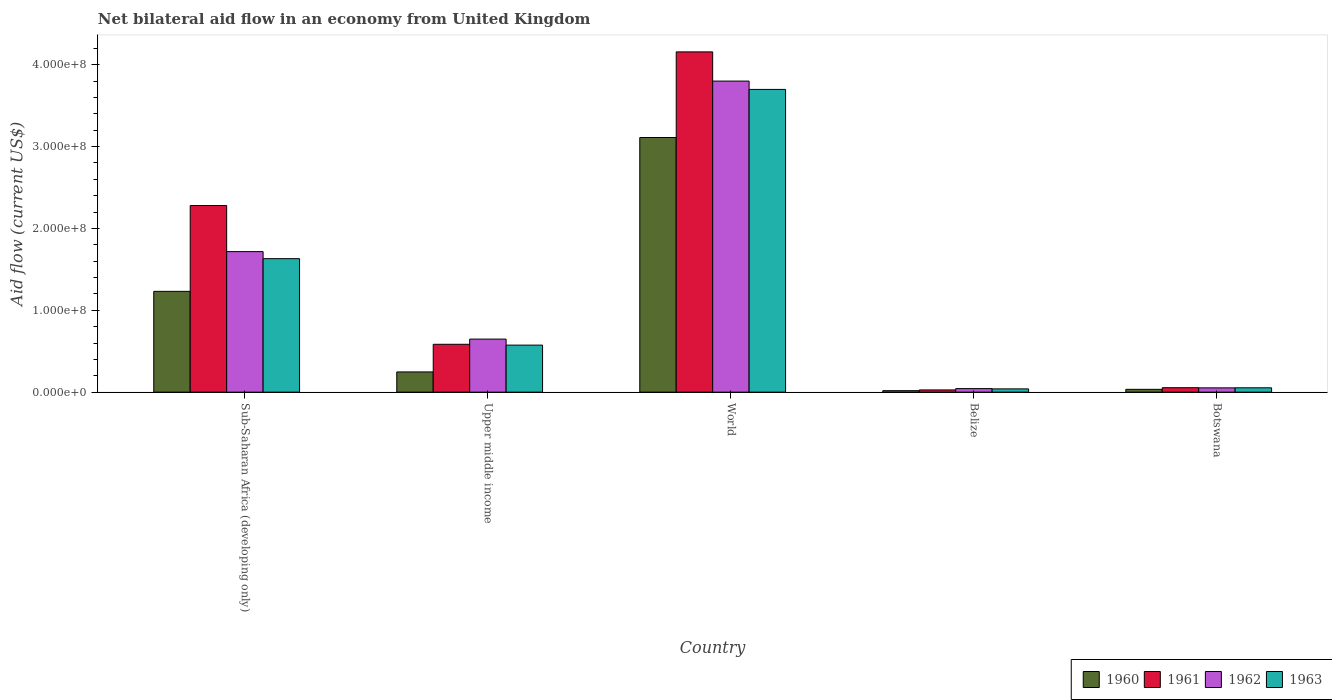How many different coloured bars are there?
Offer a very short reply. 4. Are the number of bars on each tick of the X-axis equal?
Ensure brevity in your answer.  Yes. What is the label of the 5th group of bars from the left?
Provide a succinct answer. Botswana. What is the net bilateral aid flow in 1961 in Upper middle income?
Offer a terse response. 5.85e+07. Across all countries, what is the maximum net bilateral aid flow in 1962?
Offer a very short reply. 3.80e+08. Across all countries, what is the minimum net bilateral aid flow in 1962?
Ensure brevity in your answer.  4.33e+06. In which country was the net bilateral aid flow in 1963 minimum?
Offer a terse response. Belize. What is the total net bilateral aid flow in 1963 in the graph?
Provide a short and direct response. 6.00e+08. What is the difference between the net bilateral aid flow in 1962 in Upper middle income and that in World?
Your answer should be very brief. -3.15e+08. What is the difference between the net bilateral aid flow in 1962 in Botswana and the net bilateral aid flow in 1960 in World?
Offer a terse response. -3.06e+08. What is the average net bilateral aid flow in 1963 per country?
Give a very brief answer. 1.20e+08. What is the difference between the net bilateral aid flow of/in 1963 and net bilateral aid flow of/in 1960 in World?
Offer a terse response. 5.88e+07. In how many countries, is the net bilateral aid flow in 1960 greater than 400000000 US$?
Your answer should be very brief. 0. What is the ratio of the net bilateral aid flow in 1961 in Belize to that in Sub-Saharan Africa (developing only)?
Your answer should be compact. 0.01. Is the difference between the net bilateral aid flow in 1963 in Botswana and Sub-Saharan Africa (developing only) greater than the difference between the net bilateral aid flow in 1960 in Botswana and Sub-Saharan Africa (developing only)?
Provide a succinct answer. No. What is the difference between the highest and the second highest net bilateral aid flow in 1963?
Offer a very short reply. 3.12e+08. What is the difference between the highest and the lowest net bilateral aid flow in 1960?
Provide a succinct answer. 3.09e+08. What does the 2nd bar from the right in Upper middle income represents?
Provide a short and direct response. 1962. How many countries are there in the graph?
Make the answer very short. 5. What is the difference between two consecutive major ticks on the Y-axis?
Make the answer very short. 1.00e+08. Are the values on the major ticks of Y-axis written in scientific E-notation?
Make the answer very short. Yes. How many legend labels are there?
Offer a terse response. 4. How are the legend labels stacked?
Give a very brief answer. Horizontal. What is the title of the graph?
Keep it short and to the point. Net bilateral aid flow in an economy from United Kingdom. Does "1967" appear as one of the legend labels in the graph?
Your answer should be very brief. No. What is the label or title of the X-axis?
Keep it short and to the point. Country. What is the label or title of the Y-axis?
Offer a very short reply. Aid flow (current US$). What is the Aid flow (current US$) of 1960 in Sub-Saharan Africa (developing only)?
Ensure brevity in your answer.  1.23e+08. What is the Aid flow (current US$) in 1961 in Sub-Saharan Africa (developing only)?
Ensure brevity in your answer.  2.28e+08. What is the Aid flow (current US$) of 1962 in Sub-Saharan Africa (developing only)?
Ensure brevity in your answer.  1.72e+08. What is the Aid flow (current US$) in 1963 in Sub-Saharan Africa (developing only)?
Ensure brevity in your answer.  1.63e+08. What is the Aid flow (current US$) in 1960 in Upper middle income?
Your answer should be compact. 2.47e+07. What is the Aid flow (current US$) in 1961 in Upper middle income?
Make the answer very short. 5.85e+07. What is the Aid flow (current US$) of 1962 in Upper middle income?
Keep it short and to the point. 6.48e+07. What is the Aid flow (current US$) of 1963 in Upper middle income?
Your answer should be compact. 5.74e+07. What is the Aid flow (current US$) of 1960 in World?
Provide a succinct answer. 3.11e+08. What is the Aid flow (current US$) of 1961 in World?
Keep it short and to the point. 4.16e+08. What is the Aid flow (current US$) in 1962 in World?
Provide a short and direct response. 3.80e+08. What is the Aid flow (current US$) in 1963 in World?
Ensure brevity in your answer.  3.70e+08. What is the Aid flow (current US$) of 1960 in Belize?
Give a very brief answer. 1.79e+06. What is the Aid flow (current US$) in 1961 in Belize?
Make the answer very short. 2.70e+06. What is the Aid flow (current US$) of 1962 in Belize?
Provide a short and direct response. 4.33e+06. What is the Aid flow (current US$) in 1963 in Belize?
Your response must be concise. 3.99e+06. What is the Aid flow (current US$) of 1960 in Botswana?
Offer a terse response. 3.43e+06. What is the Aid flow (current US$) in 1961 in Botswana?
Your answer should be compact. 5.44e+06. What is the Aid flow (current US$) of 1962 in Botswana?
Keep it short and to the point. 5.22e+06. What is the Aid flow (current US$) in 1963 in Botswana?
Offer a terse response. 5.30e+06. Across all countries, what is the maximum Aid flow (current US$) of 1960?
Give a very brief answer. 3.11e+08. Across all countries, what is the maximum Aid flow (current US$) in 1961?
Your answer should be very brief. 4.16e+08. Across all countries, what is the maximum Aid flow (current US$) in 1962?
Provide a short and direct response. 3.80e+08. Across all countries, what is the maximum Aid flow (current US$) of 1963?
Ensure brevity in your answer.  3.70e+08. Across all countries, what is the minimum Aid flow (current US$) in 1960?
Your answer should be very brief. 1.79e+06. Across all countries, what is the minimum Aid flow (current US$) in 1961?
Give a very brief answer. 2.70e+06. Across all countries, what is the minimum Aid flow (current US$) in 1962?
Keep it short and to the point. 4.33e+06. Across all countries, what is the minimum Aid flow (current US$) in 1963?
Your response must be concise. 3.99e+06. What is the total Aid flow (current US$) of 1960 in the graph?
Ensure brevity in your answer.  4.64e+08. What is the total Aid flow (current US$) of 1961 in the graph?
Keep it short and to the point. 7.10e+08. What is the total Aid flow (current US$) in 1962 in the graph?
Keep it short and to the point. 6.26e+08. What is the total Aid flow (current US$) in 1963 in the graph?
Your response must be concise. 6.00e+08. What is the difference between the Aid flow (current US$) of 1960 in Sub-Saharan Africa (developing only) and that in Upper middle income?
Your answer should be very brief. 9.84e+07. What is the difference between the Aid flow (current US$) in 1961 in Sub-Saharan Africa (developing only) and that in Upper middle income?
Your answer should be compact. 1.69e+08. What is the difference between the Aid flow (current US$) of 1962 in Sub-Saharan Africa (developing only) and that in Upper middle income?
Provide a succinct answer. 1.07e+08. What is the difference between the Aid flow (current US$) in 1963 in Sub-Saharan Africa (developing only) and that in Upper middle income?
Your response must be concise. 1.06e+08. What is the difference between the Aid flow (current US$) in 1960 in Sub-Saharan Africa (developing only) and that in World?
Your answer should be compact. -1.88e+08. What is the difference between the Aid flow (current US$) of 1961 in Sub-Saharan Africa (developing only) and that in World?
Your response must be concise. -1.88e+08. What is the difference between the Aid flow (current US$) of 1962 in Sub-Saharan Africa (developing only) and that in World?
Offer a very short reply. -2.08e+08. What is the difference between the Aid flow (current US$) in 1963 in Sub-Saharan Africa (developing only) and that in World?
Ensure brevity in your answer.  -2.07e+08. What is the difference between the Aid flow (current US$) in 1960 in Sub-Saharan Africa (developing only) and that in Belize?
Your answer should be compact. 1.21e+08. What is the difference between the Aid flow (current US$) of 1961 in Sub-Saharan Africa (developing only) and that in Belize?
Provide a short and direct response. 2.25e+08. What is the difference between the Aid flow (current US$) of 1962 in Sub-Saharan Africa (developing only) and that in Belize?
Your answer should be compact. 1.67e+08. What is the difference between the Aid flow (current US$) of 1963 in Sub-Saharan Africa (developing only) and that in Belize?
Provide a succinct answer. 1.59e+08. What is the difference between the Aid flow (current US$) in 1960 in Sub-Saharan Africa (developing only) and that in Botswana?
Make the answer very short. 1.20e+08. What is the difference between the Aid flow (current US$) of 1961 in Sub-Saharan Africa (developing only) and that in Botswana?
Your response must be concise. 2.22e+08. What is the difference between the Aid flow (current US$) in 1962 in Sub-Saharan Africa (developing only) and that in Botswana?
Offer a terse response. 1.66e+08. What is the difference between the Aid flow (current US$) of 1963 in Sub-Saharan Africa (developing only) and that in Botswana?
Give a very brief answer. 1.58e+08. What is the difference between the Aid flow (current US$) of 1960 in Upper middle income and that in World?
Provide a short and direct response. -2.86e+08. What is the difference between the Aid flow (current US$) in 1961 in Upper middle income and that in World?
Your answer should be very brief. -3.57e+08. What is the difference between the Aid flow (current US$) in 1962 in Upper middle income and that in World?
Offer a terse response. -3.15e+08. What is the difference between the Aid flow (current US$) of 1963 in Upper middle income and that in World?
Your answer should be compact. -3.12e+08. What is the difference between the Aid flow (current US$) of 1960 in Upper middle income and that in Belize?
Offer a terse response. 2.29e+07. What is the difference between the Aid flow (current US$) in 1961 in Upper middle income and that in Belize?
Ensure brevity in your answer.  5.58e+07. What is the difference between the Aid flow (current US$) of 1962 in Upper middle income and that in Belize?
Your answer should be compact. 6.05e+07. What is the difference between the Aid flow (current US$) in 1963 in Upper middle income and that in Belize?
Provide a succinct answer. 5.35e+07. What is the difference between the Aid flow (current US$) in 1960 in Upper middle income and that in Botswana?
Your response must be concise. 2.13e+07. What is the difference between the Aid flow (current US$) in 1961 in Upper middle income and that in Botswana?
Make the answer very short. 5.30e+07. What is the difference between the Aid flow (current US$) of 1962 in Upper middle income and that in Botswana?
Your response must be concise. 5.96e+07. What is the difference between the Aid flow (current US$) of 1963 in Upper middle income and that in Botswana?
Your response must be concise. 5.22e+07. What is the difference between the Aid flow (current US$) in 1960 in World and that in Belize?
Provide a succinct answer. 3.09e+08. What is the difference between the Aid flow (current US$) of 1961 in World and that in Belize?
Provide a succinct answer. 4.13e+08. What is the difference between the Aid flow (current US$) of 1962 in World and that in Belize?
Your answer should be very brief. 3.76e+08. What is the difference between the Aid flow (current US$) in 1963 in World and that in Belize?
Make the answer very short. 3.66e+08. What is the difference between the Aid flow (current US$) in 1960 in World and that in Botswana?
Your response must be concise. 3.08e+08. What is the difference between the Aid flow (current US$) in 1961 in World and that in Botswana?
Provide a short and direct response. 4.10e+08. What is the difference between the Aid flow (current US$) in 1962 in World and that in Botswana?
Provide a short and direct response. 3.75e+08. What is the difference between the Aid flow (current US$) of 1963 in World and that in Botswana?
Provide a short and direct response. 3.65e+08. What is the difference between the Aid flow (current US$) of 1960 in Belize and that in Botswana?
Provide a succinct answer. -1.64e+06. What is the difference between the Aid flow (current US$) of 1961 in Belize and that in Botswana?
Offer a terse response. -2.74e+06. What is the difference between the Aid flow (current US$) of 1962 in Belize and that in Botswana?
Your response must be concise. -8.90e+05. What is the difference between the Aid flow (current US$) in 1963 in Belize and that in Botswana?
Offer a terse response. -1.31e+06. What is the difference between the Aid flow (current US$) of 1960 in Sub-Saharan Africa (developing only) and the Aid flow (current US$) of 1961 in Upper middle income?
Offer a very short reply. 6.47e+07. What is the difference between the Aid flow (current US$) of 1960 in Sub-Saharan Africa (developing only) and the Aid flow (current US$) of 1962 in Upper middle income?
Ensure brevity in your answer.  5.83e+07. What is the difference between the Aid flow (current US$) in 1960 in Sub-Saharan Africa (developing only) and the Aid flow (current US$) in 1963 in Upper middle income?
Your answer should be compact. 6.57e+07. What is the difference between the Aid flow (current US$) of 1961 in Sub-Saharan Africa (developing only) and the Aid flow (current US$) of 1962 in Upper middle income?
Provide a succinct answer. 1.63e+08. What is the difference between the Aid flow (current US$) of 1961 in Sub-Saharan Africa (developing only) and the Aid flow (current US$) of 1963 in Upper middle income?
Give a very brief answer. 1.70e+08. What is the difference between the Aid flow (current US$) of 1962 in Sub-Saharan Africa (developing only) and the Aid flow (current US$) of 1963 in Upper middle income?
Your answer should be compact. 1.14e+08. What is the difference between the Aid flow (current US$) in 1960 in Sub-Saharan Africa (developing only) and the Aid flow (current US$) in 1961 in World?
Provide a succinct answer. -2.93e+08. What is the difference between the Aid flow (current US$) in 1960 in Sub-Saharan Africa (developing only) and the Aid flow (current US$) in 1962 in World?
Give a very brief answer. -2.57e+08. What is the difference between the Aid flow (current US$) of 1960 in Sub-Saharan Africa (developing only) and the Aid flow (current US$) of 1963 in World?
Provide a succinct answer. -2.47e+08. What is the difference between the Aid flow (current US$) of 1961 in Sub-Saharan Africa (developing only) and the Aid flow (current US$) of 1962 in World?
Make the answer very short. -1.52e+08. What is the difference between the Aid flow (current US$) of 1961 in Sub-Saharan Africa (developing only) and the Aid flow (current US$) of 1963 in World?
Offer a terse response. -1.42e+08. What is the difference between the Aid flow (current US$) in 1962 in Sub-Saharan Africa (developing only) and the Aid flow (current US$) in 1963 in World?
Give a very brief answer. -1.98e+08. What is the difference between the Aid flow (current US$) of 1960 in Sub-Saharan Africa (developing only) and the Aid flow (current US$) of 1961 in Belize?
Give a very brief answer. 1.20e+08. What is the difference between the Aid flow (current US$) of 1960 in Sub-Saharan Africa (developing only) and the Aid flow (current US$) of 1962 in Belize?
Offer a terse response. 1.19e+08. What is the difference between the Aid flow (current US$) in 1960 in Sub-Saharan Africa (developing only) and the Aid flow (current US$) in 1963 in Belize?
Your answer should be very brief. 1.19e+08. What is the difference between the Aid flow (current US$) of 1961 in Sub-Saharan Africa (developing only) and the Aid flow (current US$) of 1962 in Belize?
Keep it short and to the point. 2.24e+08. What is the difference between the Aid flow (current US$) in 1961 in Sub-Saharan Africa (developing only) and the Aid flow (current US$) in 1963 in Belize?
Make the answer very short. 2.24e+08. What is the difference between the Aid flow (current US$) in 1962 in Sub-Saharan Africa (developing only) and the Aid flow (current US$) in 1963 in Belize?
Provide a succinct answer. 1.68e+08. What is the difference between the Aid flow (current US$) of 1960 in Sub-Saharan Africa (developing only) and the Aid flow (current US$) of 1961 in Botswana?
Ensure brevity in your answer.  1.18e+08. What is the difference between the Aid flow (current US$) in 1960 in Sub-Saharan Africa (developing only) and the Aid flow (current US$) in 1962 in Botswana?
Offer a terse response. 1.18e+08. What is the difference between the Aid flow (current US$) in 1960 in Sub-Saharan Africa (developing only) and the Aid flow (current US$) in 1963 in Botswana?
Offer a very short reply. 1.18e+08. What is the difference between the Aid flow (current US$) of 1961 in Sub-Saharan Africa (developing only) and the Aid flow (current US$) of 1962 in Botswana?
Ensure brevity in your answer.  2.23e+08. What is the difference between the Aid flow (current US$) of 1961 in Sub-Saharan Africa (developing only) and the Aid flow (current US$) of 1963 in Botswana?
Give a very brief answer. 2.23e+08. What is the difference between the Aid flow (current US$) in 1962 in Sub-Saharan Africa (developing only) and the Aid flow (current US$) in 1963 in Botswana?
Ensure brevity in your answer.  1.66e+08. What is the difference between the Aid flow (current US$) in 1960 in Upper middle income and the Aid flow (current US$) in 1961 in World?
Your response must be concise. -3.91e+08. What is the difference between the Aid flow (current US$) in 1960 in Upper middle income and the Aid flow (current US$) in 1962 in World?
Your answer should be compact. -3.55e+08. What is the difference between the Aid flow (current US$) in 1960 in Upper middle income and the Aid flow (current US$) in 1963 in World?
Provide a succinct answer. -3.45e+08. What is the difference between the Aid flow (current US$) in 1961 in Upper middle income and the Aid flow (current US$) in 1962 in World?
Keep it short and to the point. -3.22e+08. What is the difference between the Aid flow (current US$) of 1961 in Upper middle income and the Aid flow (current US$) of 1963 in World?
Your answer should be compact. -3.11e+08. What is the difference between the Aid flow (current US$) of 1962 in Upper middle income and the Aid flow (current US$) of 1963 in World?
Your response must be concise. -3.05e+08. What is the difference between the Aid flow (current US$) of 1960 in Upper middle income and the Aid flow (current US$) of 1961 in Belize?
Your answer should be very brief. 2.20e+07. What is the difference between the Aid flow (current US$) of 1960 in Upper middle income and the Aid flow (current US$) of 1962 in Belize?
Give a very brief answer. 2.04e+07. What is the difference between the Aid flow (current US$) of 1960 in Upper middle income and the Aid flow (current US$) of 1963 in Belize?
Offer a very short reply. 2.07e+07. What is the difference between the Aid flow (current US$) of 1961 in Upper middle income and the Aid flow (current US$) of 1962 in Belize?
Provide a short and direct response. 5.41e+07. What is the difference between the Aid flow (current US$) of 1961 in Upper middle income and the Aid flow (current US$) of 1963 in Belize?
Your answer should be very brief. 5.45e+07. What is the difference between the Aid flow (current US$) in 1962 in Upper middle income and the Aid flow (current US$) in 1963 in Belize?
Provide a short and direct response. 6.08e+07. What is the difference between the Aid flow (current US$) of 1960 in Upper middle income and the Aid flow (current US$) of 1961 in Botswana?
Provide a short and direct response. 1.93e+07. What is the difference between the Aid flow (current US$) in 1960 in Upper middle income and the Aid flow (current US$) in 1962 in Botswana?
Give a very brief answer. 1.95e+07. What is the difference between the Aid flow (current US$) in 1960 in Upper middle income and the Aid flow (current US$) in 1963 in Botswana?
Offer a very short reply. 1.94e+07. What is the difference between the Aid flow (current US$) in 1961 in Upper middle income and the Aid flow (current US$) in 1962 in Botswana?
Provide a succinct answer. 5.32e+07. What is the difference between the Aid flow (current US$) in 1961 in Upper middle income and the Aid flow (current US$) in 1963 in Botswana?
Offer a very short reply. 5.32e+07. What is the difference between the Aid flow (current US$) in 1962 in Upper middle income and the Aid flow (current US$) in 1963 in Botswana?
Make the answer very short. 5.95e+07. What is the difference between the Aid flow (current US$) of 1960 in World and the Aid flow (current US$) of 1961 in Belize?
Your answer should be very brief. 3.08e+08. What is the difference between the Aid flow (current US$) of 1960 in World and the Aid flow (current US$) of 1962 in Belize?
Ensure brevity in your answer.  3.07e+08. What is the difference between the Aid flow (current US$) of 1960 in World and the Aid flow (current US$) of 1963 in Belize?
Offer a terse response. 3.07e+08. What is the difference between the Aid flow (current US$) in 1961 in World and the Aid flow (current US$) in 1962 in Belize?
Keep it short and to the point. 4.11e+08. What is the difference between the Aid flow (current US$) of 1961 in World and the Aid flow (current US$) of 1963 in Belize?
Provide a succinct answer. 4.12e+08. What is the difference between the Aid flow (current US$) of 1962 in World and the Aid flow (current US$) of 1963 in Belize?
Give a very brief answer. 3.76e+08. What is the difference between the Aid flow (current US$) in 1960 in World and the Aid flow (current US$) in 1961 in Botswana?
Offer a very short reply. 3.06e+08. What is the difference between the Aid flow (current US$) in 1960 in World and the Aid flow (current US$) in 1962 in Botswana?
Your response must be concise. 3.06e+08. What is the difference between the Aid flow (current US$) of 1960 in World and the Aid flow (current US$) of 1963 in Botswana?
Keep it short and to the point. 3.06e+08. What is the difference between the Aid flow (current US$) of 1961 in World and the Aid flow (current US$) of 1962 in Botswana?
Give a very brief answer. 4.10e+08. What is the difference between the Aid flow (current US$) in 1961 in World and the Aid flow (current US$) in 1963 in Botswana?
Provide a succinct answer. 4.10e+08. What is the difference between the Aid flow (current US$) in 1962 in World and the Aid flow (current US$) in 1963 in Botswana?
Offer a very short reply. 3.75e+08. What is the difference between the Aid flow (current US$) in 1960 in Belize and the Aid flow (current US$) in 1961 in Botswana?
Provide a short and direct response. -3.65e+06. What is the difference between the Aid flow (current US$) of 1960 in Belize and the Aid flow (current US$) of 1962 in Botswana?
Give a very brief answer. -3.43e+06. What is the difference between the Aid flow (current US$) of 1960 in Belize and the Aid flow (current US$) of 1963 in Botswana?
Your response must be concise. -3.51e+06. What is the difference between the Aid flow (current US$) of 1961 in Belize and the Aid flow (current US$) of 1962 in Botswana?
Offer a terse response. -2.52e+06. What is the difference between the Aid flow (current US$) in 1961 in Belize and the Aid flow (current US$) in 1963 in Botswana?
Your response must be concise. -2.60e+06. What is the difference between the Aid flow (current US$) in 1962 in Belize and the Aid flow (current US$) in 1963 in Botswana?
Offer a very short reply. -9.70e+05. What is the average Aid flow (current US$) in 1960 per country?
Provide a short and direct response. 9.28e+07. What is the average Aid flow (current US$) in 1961 per country?
Your response must be concise. 1.42e+08. What is the average Aid flow (current US$) in 1962 per country?
Provide a succinct answer. 1.25e+08. What is the average Aid flow (current US$) of 1963 per country?
Provide a short and direct response. 1.20e+08. What is the difference between the Aid flow (current US$) in 1960 and Aid flow (current US$) in 1961 in Sub-Saharan Africa (developing only)?
Provide a short and direct response. -1.05e+08. What is the difference between the Aid flow (current US$) of 1960 and Aid flow (current US$) of 1962 in Sub-Saharan Africa (developing only)?
Provide a succinct answer. -4.85e+07. What is the difference between the Aid flow (current US$) in 1960 and Aid flow (current US$) in 1963 in Sub-Saharan Africa (developing only)?
Keep it short and to the point. -3.99e+07. What is the difference between the Aid flow (current US$) in 1961 and Aid flow (current US$) in 1962 in Sub-Saharan Africa (developing only)?
Offer a terse response. 5.63e+07. What is the difference between the Aid flow (current US$) of 1961 and Aid flow (current US$) of 1963 in Sub-Saharan Africa (developing only)?
Ensure brevity in your answer.  6.49e+07. What is the difference between the Aid flow (current US$) of 1962 and Aid flow (current US$) of 1963 in Sub-Saharan Africa (developing only)?
Your response must be concise. 8.61e+06. What is the difference between the Aid flow (current US$) of 1960 and Aid flow (current US$) of 1961 in Upper middle income?
Make the answer very short. -3.38e+07. What is the difference between the Aid flow (current US$) of 1960 and Aid flow (current US$) of 1962 in Upper middle income?
Provide a succinct answer. -4.01e+07. What is the difference between the Aid flow (current US$) in 1960 and Aid flow (current US$) in 1963 in Upper middle income?
Your answer should be very brief. -3.28e+07. What is the difference between the Aid flow (current US$) of 1961 and Aid flow (current US$) of 1962 in Upper middle income?
Ensure brevity in your answer.  -6.33e+06. What is the difference between the Aid flow (current US$) in 1961 and Aid flow (current US$) in 1963 in Upper middle income?
Provide a succinct answer. 1.02e+06. What is the difference between the Aid flow (current US$) in 1962 and Aid flow (current US$) in 1963 in Upper middle income?
Provide a short and direct response. 7.35e+06. What is the difference between the Aid flow (current US$) of 1960 and Aid flow (current US$) of 1961 in World?
Ensure brevity in your answer.  -1.05e+08. What is the difference between the Aid flow (current US$) of 1960 and Aid flow (current US$) of 1962 in World?
Offer a terse response. -6.89e+07. What is the difference between the Aid flow (current US$) of 1960 and Aid flow (current US$) of 1963 in World?
Provide a short and direct response. -5.88e+07. What is the difference between the Aid flow (current US$) in 1961 and Aid flow (current US$) in 1962 in World?
Provide a short and direct response. 3.57e+07. What is the difference between the Aid flow (current US$) of 1961 and Aid flow (current US$) of 1963 in World?
Provide a succinct answer. 4.58e+07. What is the difference between the Aid flow (current US$) of 1962 and Aid flow (current US$) of 1963 in World?
Your response must be concise. 1.02e+07. What is the difference between the Aid flow (current US$) of 1960 and Aid flow (current US$) of 1961 in Belize?
Your response must be concise. -9.10e+05. What is the difference between the Aid flow (current US$) in 1960 and Aid flow (current US$) in 1962 in Belize?
Provide a short and direct response. -2.54e+06. What is the difference between the Aid flow (current US$) in 1960 and Aid flow (current US$) in 1963 in Belize?
Give a very brief answer. -2.20e+06. What is the difference between the Aid flow (current US$) of 1961 and Aid flow (current US$) of 1962 in Belize?
Offer a very short reply. -1.63e+06. What is the difference between the Aid flow (current US$) in 1961 and Aid flow (current US$) in 1963 in Belize?
Your answer should be compact. -1.29e+06. What is the difference between the Aid flow (current US$) in 1962 and Aid flow (current US$) in 1963 in Belize?
Your answer should be compact. 3.40e+05. What is the difference between the Aid flow (current US$) of 1960 and Aid flow (current US$) of 1961 in Botswana?
Give a very brief answer. -2.01e+06. What is the difference between the Aid flow (current US$) of 1960 and Aid flow (current US$) of 1962 in Botswana?
Offer a very short reply. -1.79e+06. What is the difference between the Aid flow (current US$) of 1960 and Aid flow (current US$) of 1963 in Botswana?
Offer a terse response. -1.87e+06. What is the difference between the Aid flow (current US$) of 1962 and Aid flow (current US$) of 1963 in Botswana?
Offer a very short reply. -8.00e+04. What is the ratio of the Aid flow (current US$) of 1960 in Sub-Saharan Africa (developing only) to that in Upper middle income?
Give a very brief answer. 4.99. What is the ratio of the Aid flow (current US$) of 1961 in Sub-Saharan Africa (developing only) to that in Upper middle income?
Offer a terse response. 3.9. What is the ratio of the Aid flow (current US$) of 1962 in Sub-Saharan Africa (developing only) to that in Upper middle income?
Provide a succinct answer. 2.65. What is the ratio of the Aid flow (current US$) of 1963 in Sub-Saharan Africa (developing only) to that in Upper middle income?
Your answer should be very brief. 2.84. What is the ratio of the Aid flow (current US$) in 1960 in Sub-Saharan Africa (developing only) to that in World?
Make the answer very short. 0.4. What is the ratio of the Aid flow (current US$) of 1961 in Sub-Saharan Africa (developing only) to that in World?
Keep it short and to the point. 0.55. What is the ratio of the Aid flow (current US$) of 1962 in Sub-Saharan Africa (developing only) to that in World?
Make the answer very short. 0.45. What is the ratio of the Aid flow (current US$) in 1963 in Sub-Saharan Africa (developing only) to that in World?
Offer a terse response. 0.44. What is the ratio of the Aid flow (current US$) of 1960 in Sub-Saharan Africa (developing only) to that in Belize?
Ensure brevity in your answer.  68.79. What is the ratio of the Aid flow (current US$) in 1961 in Sub-Saharan Africa (developing only) to that in Belize?
Provide a succinct answer. 84.42. What is the ratio of the Aid flow (current US$) of 1962 in Sub-Saharan Africa (developing only) to that in Belize?
Provide a succinct answer. 39.65. What is the ratio of the Aid flow (current US$) of 1963 in Sub-Saharan Africa (developing only) to that in Belize?
Make the answer very short. 40.87. What is the ratio of the Aid flow (current US$) in 1960 in Sub-Saharan Africa (developing only) to that in Botswana?
Offer a very short reply. 35.9. What is the ratio of the Aid flow (current US$) in 1961 in Sub-Saharan Africa (developing only) to that in Botswana?
Keep it short and to the point. 41.9. What is the ratio of the Aid flow (current US$) of 1962 in Sub-Saharan Africa (developing only) to that in Botswana?
Your answer should be compact. 32.89. What is the ratio of the Aid flow (current US$) in 1963 in Sub-Saharan Africa (developing only) to that in Botswana?
Your response must be concise. 30.77. What is the ratio of the Aid flow (current US$) in 1960 in Upper middle income to that in World?
Offer a very short reply. 0.08. What is the ratio of the Aid flow (current US$) in 1961 in Upper middle income to that in World?
Provide a succinct answer. 0.14. What is the ratio of the Aid flow (current US$) in 1962 in Upper middle income to that in World?
Offer a very short reply. 0.17. What is the ratio of the Aid flow (current US$) in 1963 in Upper middle income to that in World?
Provide a succinct answer. 0.16. What is the ratio of the Aid flow (current US$) of 1960 in Upper middle income to that in Belize?
Provide a succinct answer. 13.8. What is the ratio of the Aid flow (current US$) of 1961 in Upper middle income to that in Belize?
Offer a very short reply. 21.66. What is the ratio of the Aid flow (current US$) of 1962 in Upper middle income to that in Belize?
Keep it short and to the point. 14.97. What is the ratio of the Aid flow (current US$) of 1963 in Upper middle income to that in Belize?
Your response must be concise. 14.4. What is the ratio of the Aid flow (current US$) in 1960 in Upper middle income to that in Botswana?
Your answer should be very brief. 7.2. What is the ratio of the Aid flow (current US$) of 1961 in Upper middle income to that in Botswana?
Make the answer very short. 10.75. What is the ratio of the Aid flow (current US$) of 1962 in Upper middle income to that in Botswana?
Make the answer very short. 12.41. What is the ratio of the Aid flow (current US$) of 1963 in Upper middle income to that in Botswana?
Your response must be concise. 10.84. What is the ratio of the Aid flow (current US$) of 1960 in World to that in Belize?
Make the answer very short. 173.77. What is the ratio of the Aid flow (current US$) of 1961 in World to that in Belize?
Your answer should be compact. 153.94. What is the ratio of the Aid flow (current US$) of 1962 in World to that in Belize?
Provide a short and direct response. 87.75. What is the ratio of the Aid flow (current US$) in 1963 in World to that in Belize?
Offer a very short reply. 92.68. What is the ratio of the Aid flow (current US$) in 1960 in World to that in Botswana?
Provide a short and direct response. 90.69. What is the ratio of the Aid flow (current US$) of 1961 in World to that in Botswana?
Offer a very short reply. 76.4. What is the ratio of the Aid flow (current US$) of 1962 in World to that in Botswana?
Make the answer very short. 72.79. What is the ratio of the Aid flow (current US$) in 1963 in World to that in Botswana?
Offer a terse response. 69.78. What is the ratio of the Aid flow (current US$) in 1960 in Belize to that in Botswana?
Make the answer very short. 0.52. What is the ratio of the Aid flow (current US$) in 1961 in Belize to that in Botswana?
Offer a very short reply. 0.5. What is the ratio of the Aid flow (current US$) of 1962 in Belize to that in Botswana?
Keep it short and to the point. 0.83. What is the ratio of the Aid flow (current US$) in 1963 in Belize to that in Botswana?
Offer a terse response. 0.75. What is the difference between the highest and the second highest Aid flow (current US$) in 1960?
Provide a succinct answer. 1.88e+08. What is the difference between the highest and the second highest Aid flow (current US$) in 1961?
Keep it short and to the point. 1.88e+08. What is the difference between the highest and the second highest Aid flow (current US$) in 1962?
Provide a succinct answer. 2.08e+08. What is the difference between the highest and the second highest Aid flow (current US$) of 1963?
Provide a short and direct response. 2.07e+08. What is the difference between the highest and the lowest Aid flow (current US$) in 1960?
Provide a succinct answer. 3.09e+08. What is the difference between the highest and the lowest Aid flow (current US$) of 1961?
Offer a terse response. 4.13e+08. What is the difference between the highest and the lowest Aid flow (current US$) of 1962?
Your answer should be very brief. 3.76e+08. What is the difference between the highest and the lowest Aid flow (current US$) in 1963?
Offer a very short reply. 3.66e+08. 